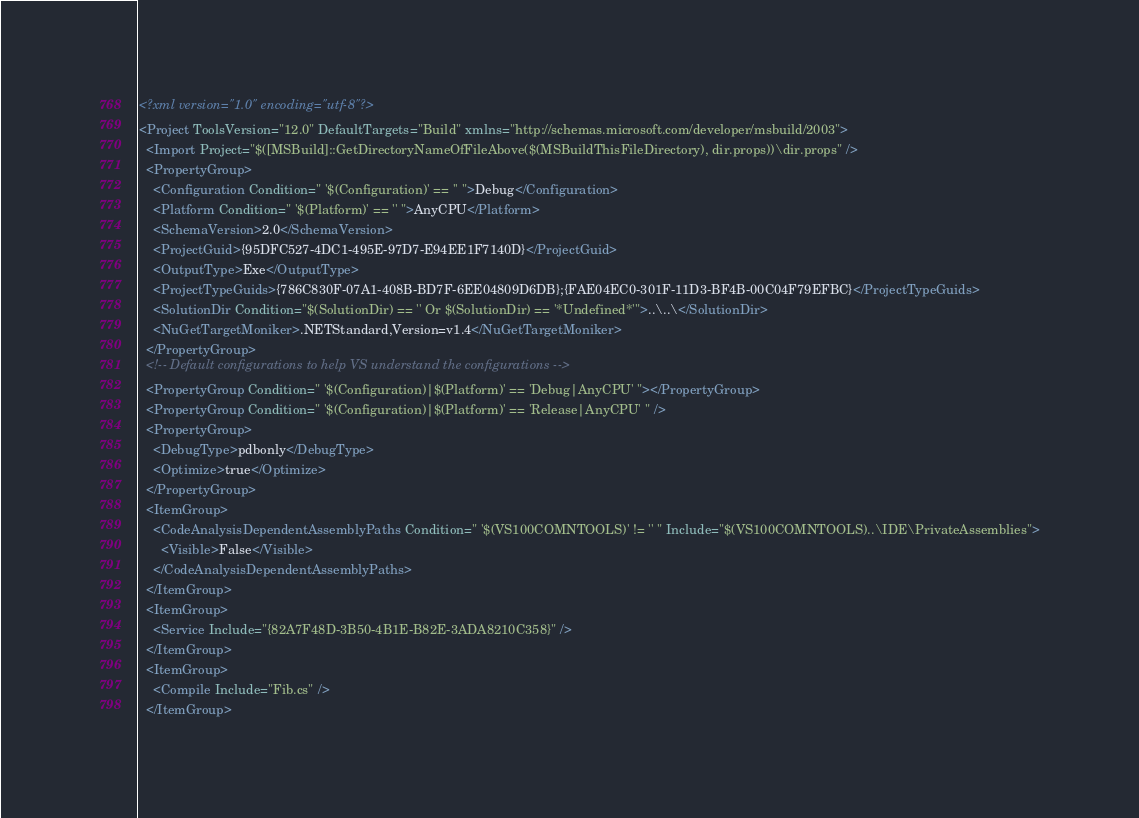Convert code to text. <code><loc_0><loc_0><loc_500><loc_500><_XML_><?xml version="1.0" encoding="utf-8"?>
<Project ToolsVersion="12.0" DefaultTargets="Build" xmlns="http://schemas.microsoft.com/developer/msbuild/2003">
  <Import Project="$([MSBuild]::GetDirectoryNameOfFileAbove($(MSBuildThisFileDirectory), dir.props))\dir.props" />
  <PropertyGroup>
    <Configuration Condition=" '$(Configuration)' == '' ">Debug</Configuration>
    <Platform Condition=" '$(Platform)' == '' ">AnyCPU</Platform>
    <SchemaVersion>2.0</SchemaVersion>
    <ProjectGuid>{95DFC527-4DC1-495E-97D7-E94EE1F7140D}</ProjectGuid>
    <OutputType>Exe</OutputType>
    <ProjectTypeGuids>{786C830F-07A1-408B-BD7F-6EE04809D6DB};{FAE04EC0-301F-11D3-BF4B-00C04F79EFBC}</ProjectTypeGuids>
    <SolutionDir Condition="$(SolutionDir) == '' Or $(SolutionDir) == '*Undefined*'">..\..\</SolutionDir>
    <NuGetTargetMoniker>.NETStandard,Version=v1.4</NuGetTargetMoniker>
  </PropertyGroup>
  <!-- Default configurations to help VS understand the configurations -->
  <PropertyGroup Condition=" '$(Configuration)|$(Platform)' == 'Debug|AnyCPU' "></PropertyGroup>
  <PropertyGroup Condition=" '$(Configuration)|$(Platform)' == 'Release|AnyCPU' " />
  <PropertyGroup>
    <DebugType>pdbonly</DebugType>
    <Optimize>true</Optimize>
  </PropertyGroup>
  <ItemGroup>
    <CodeAnalysisDependentAssemblyPaths Condition=" '$(VS100COMNTOOLS)' != '' " Include="$(VS100COMNTOOLS)..\IDE\PrivateAssemblies">
      <Visible>False</Visible>
    </CodeAnalysisDependentAssemblyPaths>
  </ItemGroup>
  <ItemGroup>
    <Service Include="{82A7F48D-3B50-4B1E-B82E-3ADA8210C358}" />
  </ItemGroup>
  <ItemGroup>
    <Compile Include="Fib.cs" />
  </ItemGroup></code> 